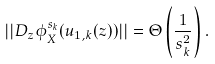Convert formula to latex. <formula><loc_0><loc_0><loc_500><loc_500>| | D _ { z } \phi _ { X } ^ { s _ { k } } ( u _ { 1 , k } ( z ) ) | | = \Theta \left ( \frac { 1 } { s _ { k } ^ { 2 } } \right ) .</formula> 